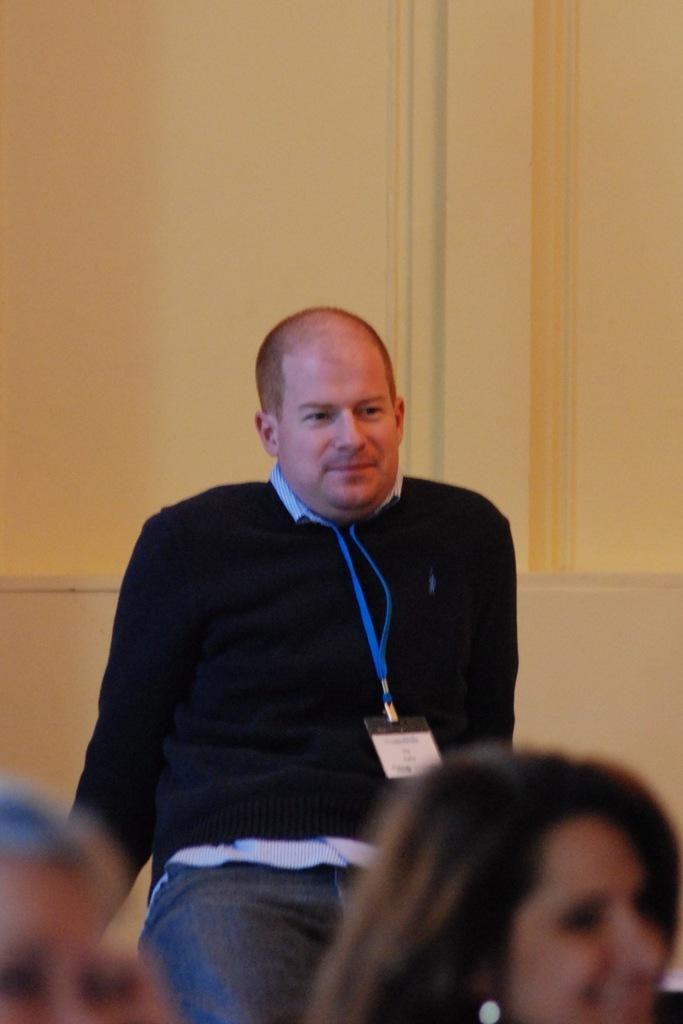What is the primary action of the man in the image? The man is standing in the image. What are the other people in the image doing? There are people sitting in the image. What can be seen in the background of the image? There is a wall in the background of the image. How many sheep are visible in the image? There are no sheep present in the image. What type of furniture can be seen in the hall in the image? There is no hall or desk present in the image. 